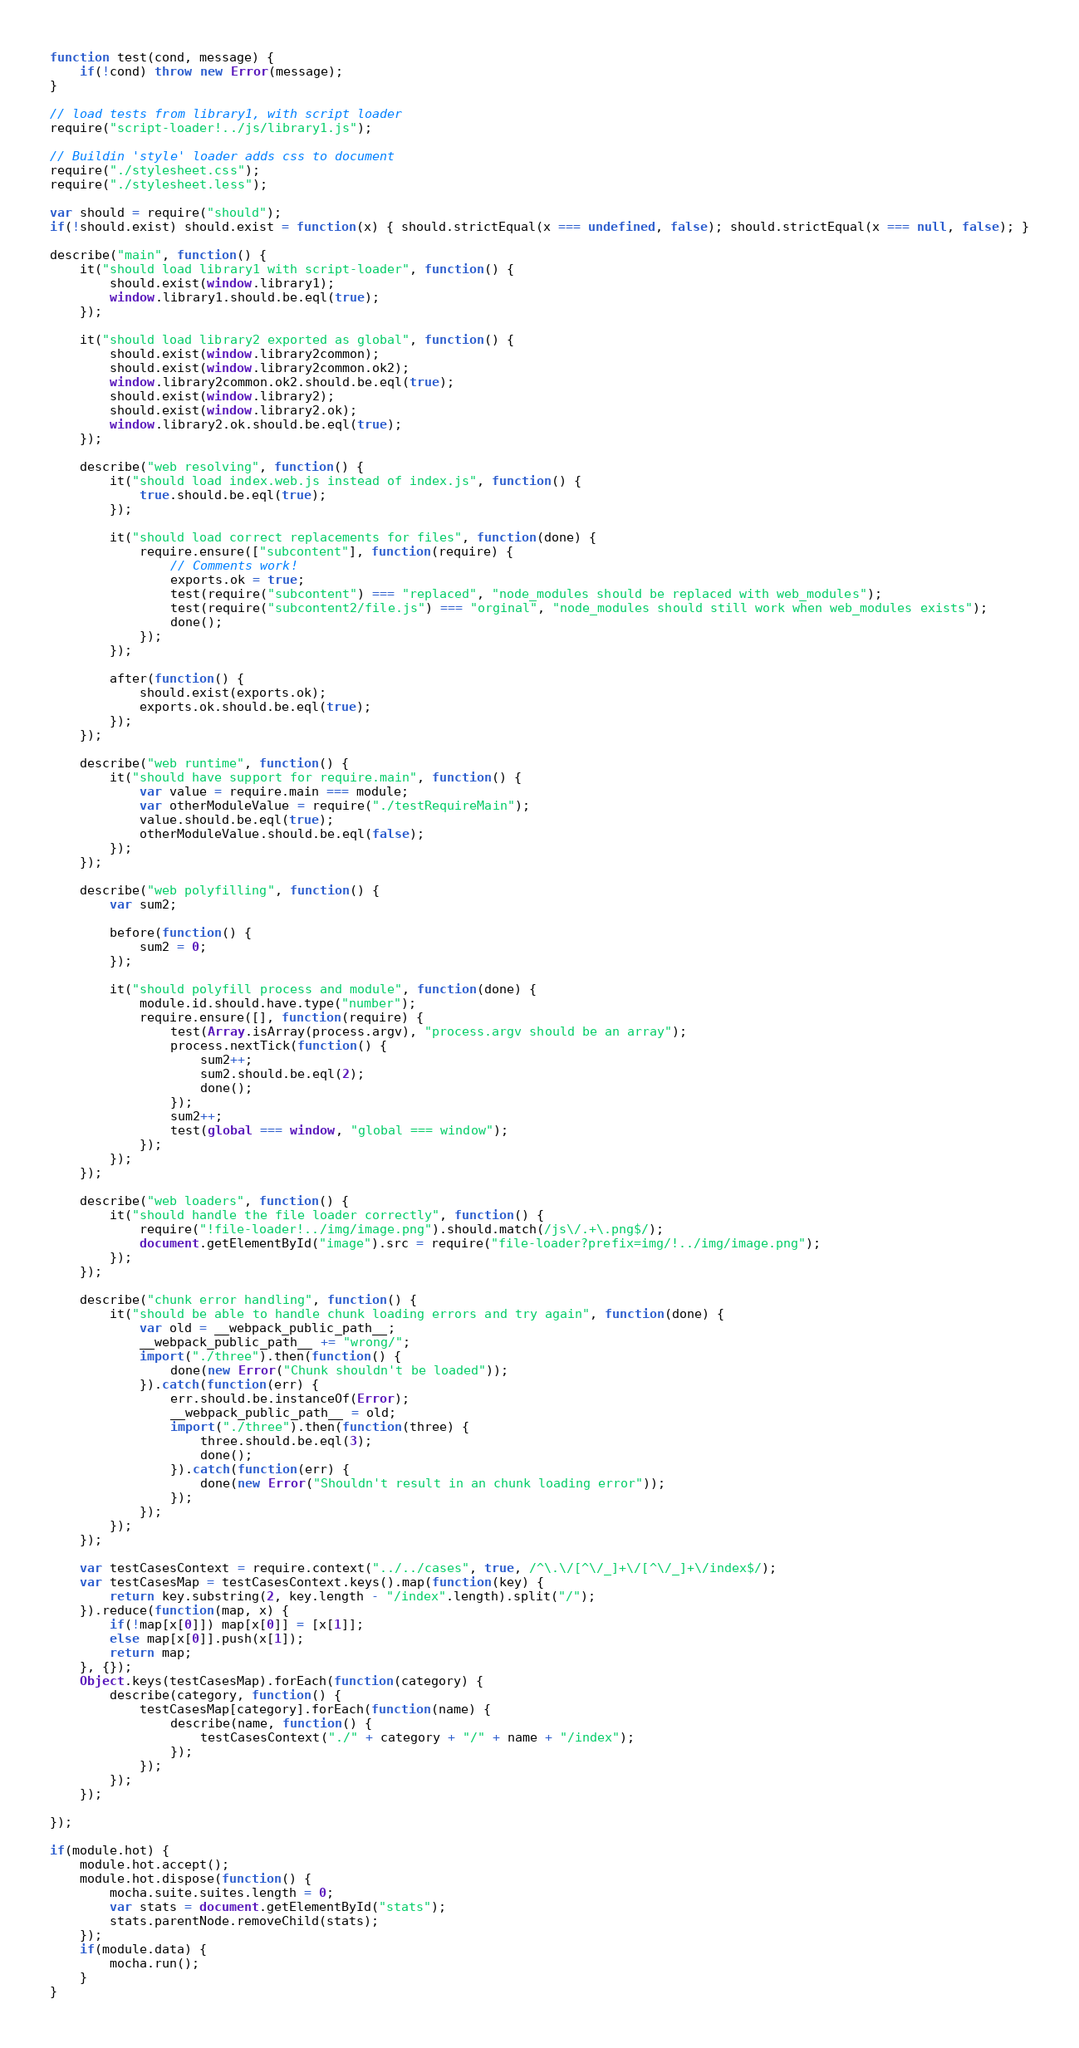<code> <loc_0><loc_0><loc_500><loc_500><_JavaScript_>function test(cond, message) {
	if(!cond) throw new Error(message);
}

// load tests from library1, with script loader
require("script-loader!../js/library1.js");

// Buildin 'style' loader adds css to document
require("./stylesheet.css");
require("./stylesheet.less");

var should = require("should");
if(!should.exist) should.exist = function(x) { should.strictEqual(x === undefined, false); should.strictEqual(x === null, false); }

describe("main", function() {
	it("should load library1 with script-loader", function() {
		should.exist(window.library1);
		window.library1.should.be.eql(true);
	});

	it("should load library2 exported as global", function() {
		should.exist(window.library2common);
		should.exist(window.library2common.ok2);
		window.library2common.ok2.should.be.eql(true);
		should.exist(window.library2);
		should.exist(window.library2.ok);
		window.library2.ok.should.be.eql(true);
	});

	describe("web resolving", function() {
		it("should load index.web.js instead of index.js", function() {
			true.should.be.eql(true);
		});

		it("should load correct replacements for files", function(done) {
			require.ensure(["subcontent"], function(require) {
				// Comments work!
				exports.ok = true;
				test(require("subcontent") === "replaced", "node_modules should be replaced with web_modules");
				test(require("subcontent2/file.js") === "orginal", "node_modules should still work when web_modules exists");
				done();
			});
		});

		after(function() {
			should.exist(exports.ok);
			exports.ok.should.be.eql(true);
		});
	});

	describe("web runtime", function() {
		it("should have support for require.main", function() {
			var value = require.main === module;
			var otherModuleValue = require("./testRequireMain");
			value.should.be.eql(true);
			otherModuleValue.should.be.eql(false);
		});
	});

	describe("web polyfilling", function() {
		var sum2;

		before(function() {
			sum2 = 0;
		});

		it("should polyfill process and module", function(done) {
			module.id.should.have.type("number");
			require.ensure([], function(require) {
				test(Array.isArray(process.argv), "process.argv should be an array");
				process.nextTick(function() {
					sum2++;
					sum2.should.be.eql(2);
					done();
				});
				sum2++;
				test(global === window, "global === window");
			});
		});
	});

	describe("web loaders", function() {
		it("should handle the file loader correctly", function() {
			require("!file-loader!../img/image.png").should.match(/js\/.+\.png$/);
			document.getElementById("image").src = require("file-loader?prefix=img/!../img/image.png");
		});
	});

	describe("chunk error handling", function() {
		it("should be able to handle chunk loading errors and try again", function(done) {
			var old = __webpack_public_path__;
			__webpack_public_path__ += "wrong/";
			import("./three").then(function() {
				done(new Error("Chunk shouldn't be loaded"));
			}).catch(function(err) {
				err.should.be.instanceOf(Error);
				__webpack_public_path__ = old;
				import("./three").then(function(three) {
					three.should.be.eql(3);
					done();
				}).catch(function(err) {
					done(new Error("Shouldn't result in an chunk loading error"));
				});
			});
		});
	});

	var testCasesContext = require.context("../../cases", true, /^\.\/[^\/_]+\/[^\/_]+\/index$/);
	var testCasesMap = testCasesContext.keys().map(function(key) {
		return key.substring(2, key.length - "/index".length).split("/");
	}).reduce(function(map, x) {
		if(!map[x[0]]) map[x[0]] = [x[1]];
		else map[x[0]].push(x[1]);
		return map;
	}, {});
	Object.keys(testCasesMap).forEach(function(category) {
		describe(category, function() {
			testCasesMap[category].forEach(function(name) {
				describe(name, function() {
					testCasesContext("./" + category + "/" + name + "/index");
				});
			});
		});
	});

});

if(module.hot) {
	module.hot.accept();
	module.hot.dispose(function() {
		mocha.suite.suites.length = 0;
		var stats = document.getElementById("stats");
		stats.parentNode.removeChild(stats);
	});
	if(module.data) {
		mocha.run();
	}
}
</code> 